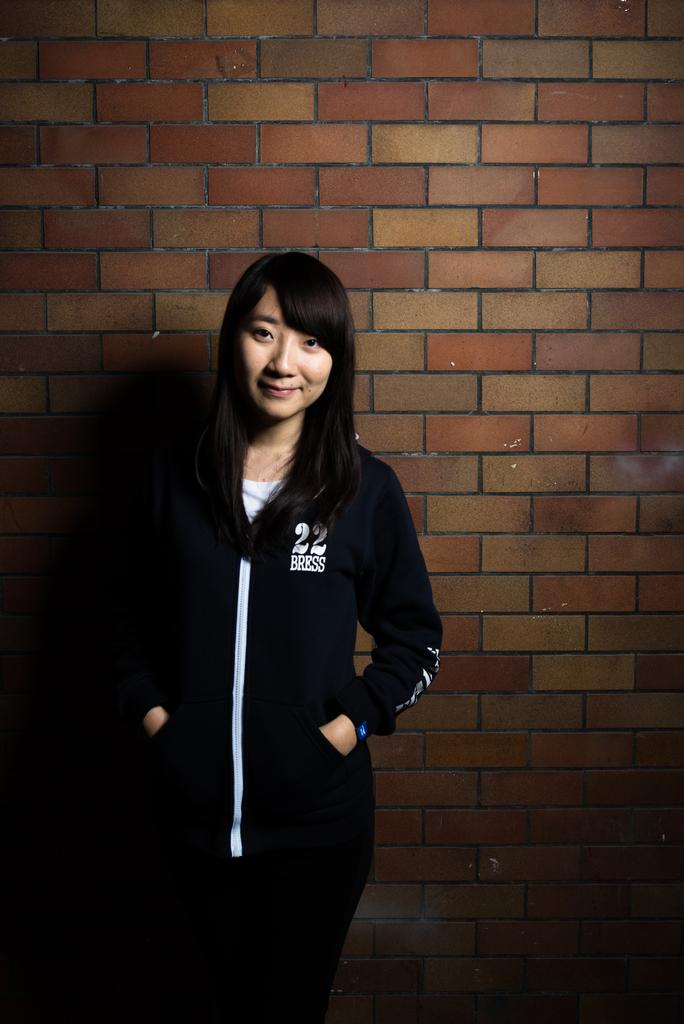What is the main subject of the image? There is a lady standing in the image. Can you describe the background of the image? There is a wall with a brick design in the image. What type of plough is the lady using in the image? There is no plough present in the image; it features a lady standing in front of a wall with a brick design. Can you tell me how many jellyfish are swimming near the lady in the image? There are no jellyfish present in the image; it features a lady standing in front of a wall with a brick design. 